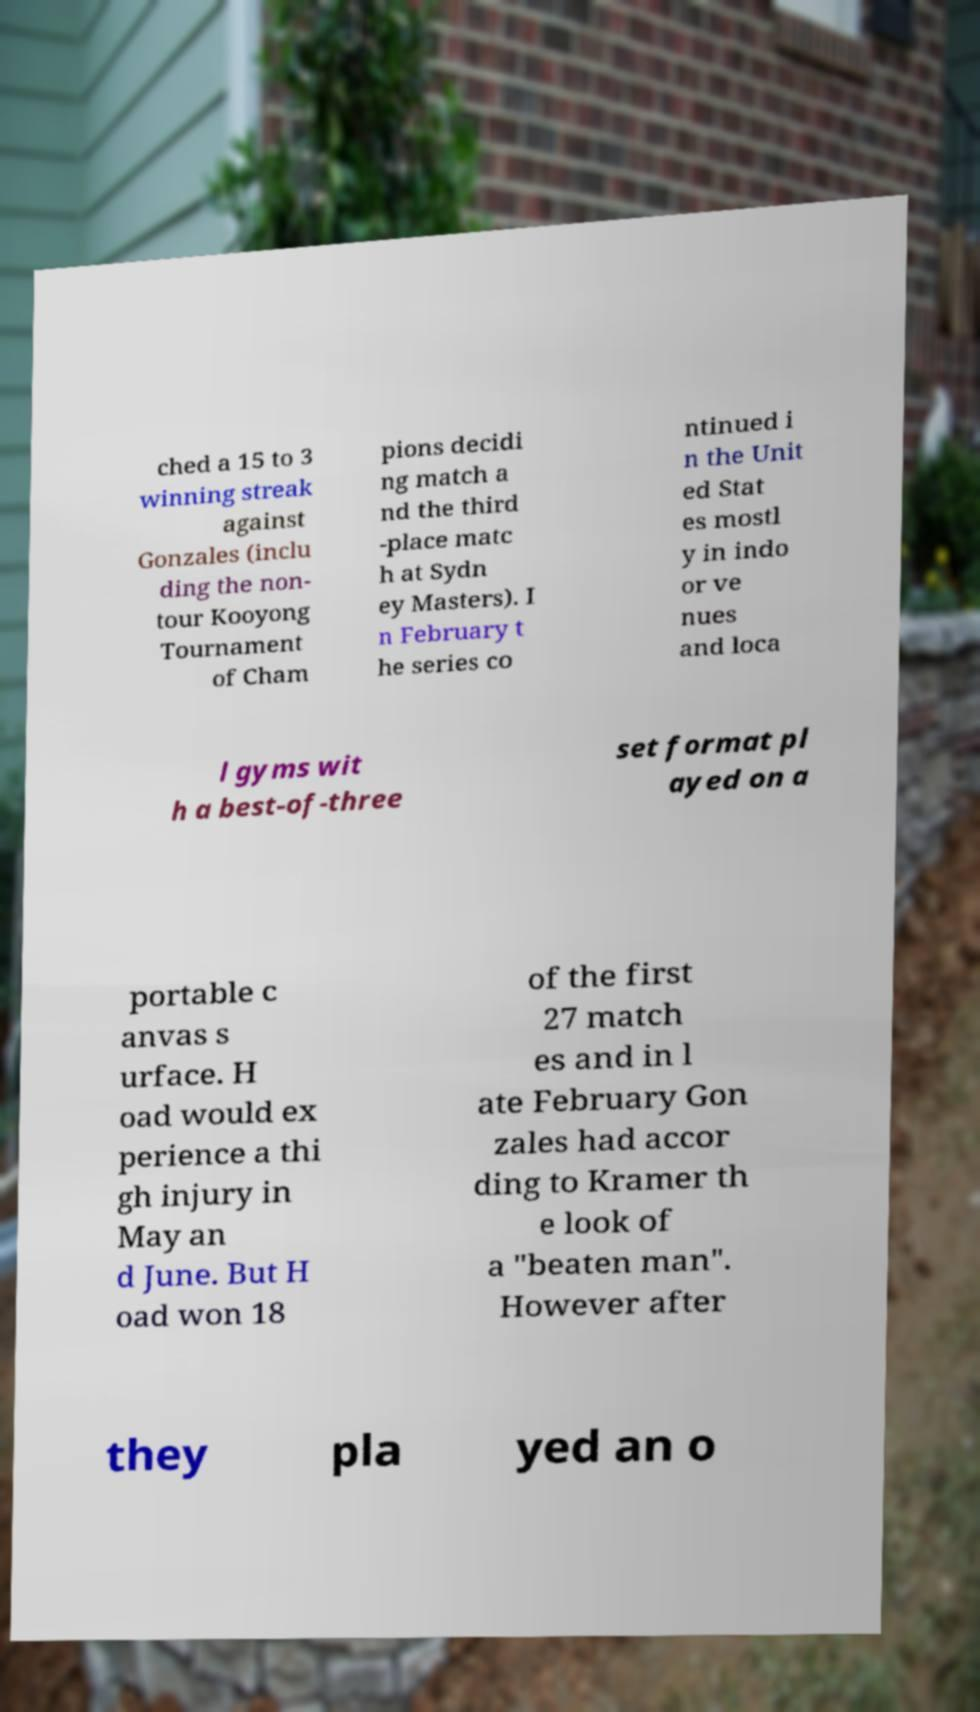There's text embedded in this image that I need extracted. Can you transcribe it verbatim? ched a 15 to 3 winning streak against Gonzales (inclu ding the non- tour Kooyong Tournament of Cham pions decidi ng match a nd the third -place matc h at Sydn ey Masters). I n February t he series co ntinued i n the Unit ed Stat es mostl y in indo or ve nues and loca l gyms wit h a best-of-three set format pl ayed on a portable c anvas s urface. H oad would ex perience a thi gh injury in May an d June. But H oad won 18 of the first 27 match es and in l ate February Gon zales had accor ding to Kramer th e look of a "beaten man". However after they pla yed an o 